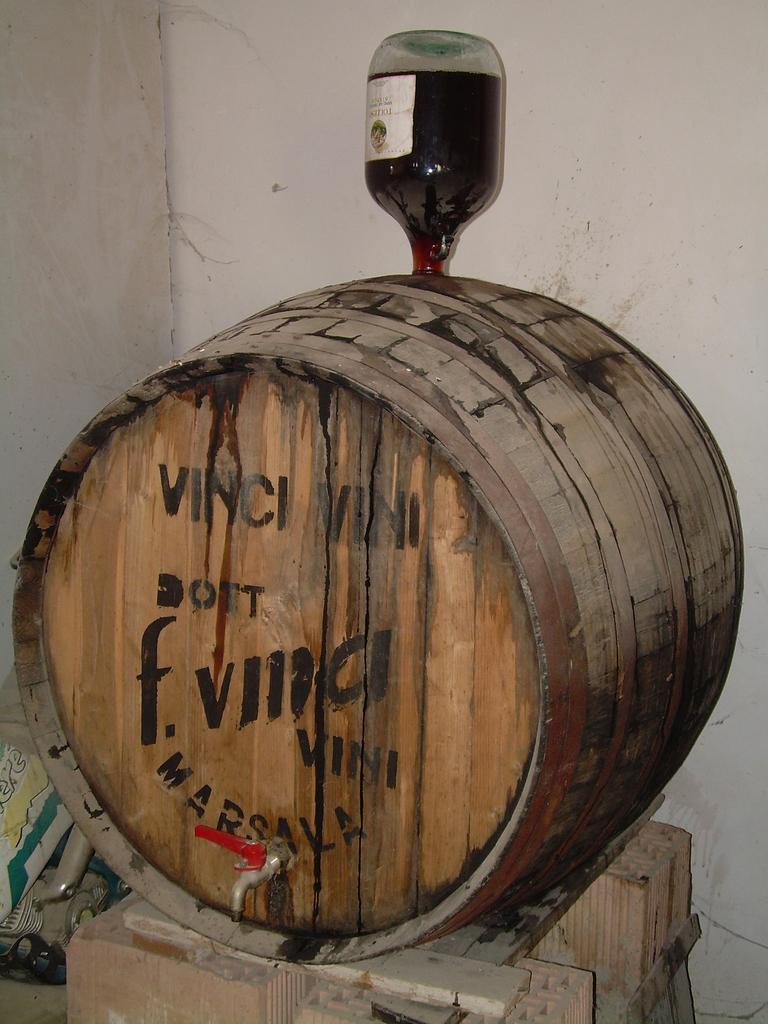What material is present in the image? There is wood in the image. What object is placed on top of the wood? There is a bottle on top of the wood. What type of structure can be seen in the image? There is a wall in the image. Can you tell me how many cats are sitting on the wall in the image? There are no cats present in the image; it features wood and a bottle on top of it, as well as a wall. Is there a goat visible in the image? There is no goat present in the image. 